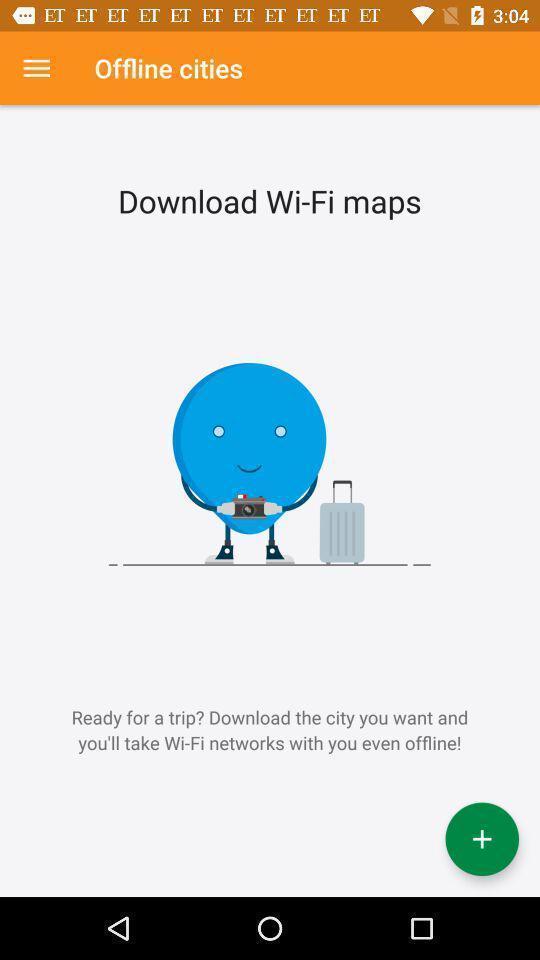Tell me about the visual elements in this screen capture. Page showing recommendation to download application. 